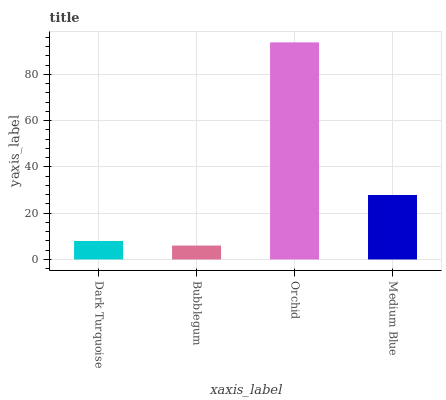Is Bubblegum the minimum?
Answer yes or no. Yes. Is Orchid the maximum?
Answer yes or no. Yes. Is Orchid the minimum?
Answer yes or no. No. Is Bubblegum the maximum?
Answer yes or no. No. Is Orchid greater than Bubblegum?
Answer yes or no. Yes. Is Bubblegum less than Orchid?
Answer yes or no. Yes. Is Bubblegum greater than Orchid?
Answer yes or no. No. Is Orchid less than Bubblegum?
Answer yes or no. No. Is Medium Blue the high median?
Answer yes or no. Yes. Is Dark Turquoise the low median?
Answer yes or no. Yes. Is Bubblegum the high median?
Answer yes or no. No. Is Bubblegum the low median?
Answer yes or no. No. 